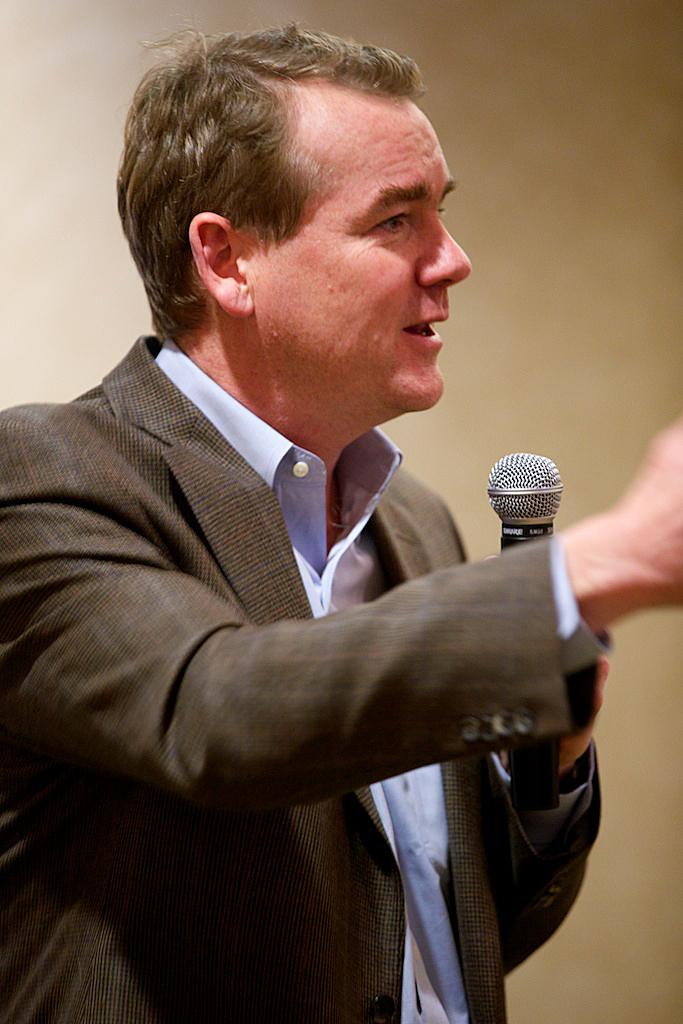What is the color of the wall in the image? The wall in the image is white. Who is present in the image? There is a man in the image. What is the man holding in the image? The man is holding a mic. How many nuts are scattered on the floor in the image? There are no nuts present in the image. 